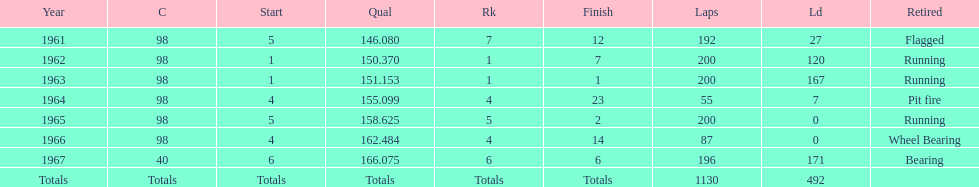Number of times to finish the races running. 3. Could you help me parse every detail presented in this table? {'header': ['Year', 'C', 'Start', 'Qual', 'Rk', 'Finish', 'Laps', 'Ld', 'Retired'], 'rows': [['1961', '98', '5', '146.080', '7', '12', '192', '27', 'Flagged'], ['1962', '98', '1', '150.370', '1', '7', '200', '120', 'Running'], ['1963', '98', '1', '151.153', '1', '1', '200', '167', 'Running'], ['1964', '98', '4', '155.099', '4', '23', '55', '7', 'Pit fire'], ['1965', '98', '5', '158.625', '5', '2', '200', '0', 'Running'], ['1966', '98', '4', '162.484', '4', '14', '87', '0', 'Wheel Bearing'], ['1967', '40', '6', '166.075', '6', '6', '196', '171', 'Bearing'], ['Totals', 'Totals', 'Totals', 'Totals', 'Totals', 'Totals', '1130', '492', '']]} 